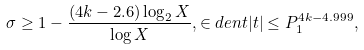Convert formula to latex. <formula><loc_0><loc_0><loc_500><loc_500>\sigma \geq 1 - \frac { ( 4 k - 2 . 6 ) \log _ { 2 } X } { \log X } , \in d e n t | t | \leq P _ { 1 } ^ { 4 k - 4 . 9 9 9 } ,</formula> 